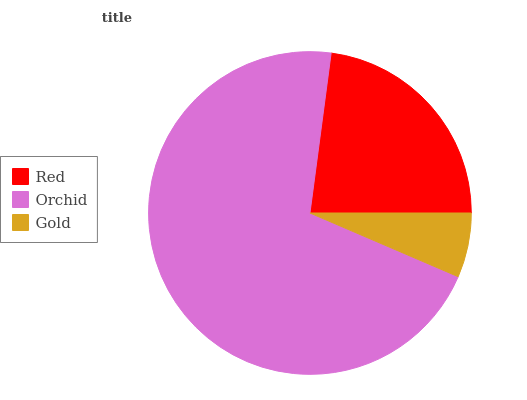Is Gold the minimum?
Answer yes or no. Yes. Is Orchid the maximum?
Answer yes or no. Yes. Is Orchid the minimum?
Answer yes or no. No. Is Gold the maximum?
Answer yes or no. No. Is Orchid greater than Gold?
Answer yes or no. Yes. Is Gold less than Orchid?
Answer yes or no. Yes. Is Gold greater than Orchid?
Answer yes or no. No. Is Orchid less than Gold?
Answer yes or no. No. Is Red the high median?
Answer yes or no. Yes. Is Red the low median?
Answer yes or no. Yes. Is Gold the high median?
Answer yes or no. No. Is Gold the low median?
Answer yes or no. No. 